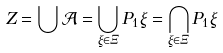<formula> <loc_0><loc_0><loc_500><loc_500>Z = \bigcup \mathcal { A } = \bigcup _ { \xi \in \Xi } P _ { 1 } \xi = \bigcap _ { \xi \in \Xi } P _ { 1 } \xi</formula> 